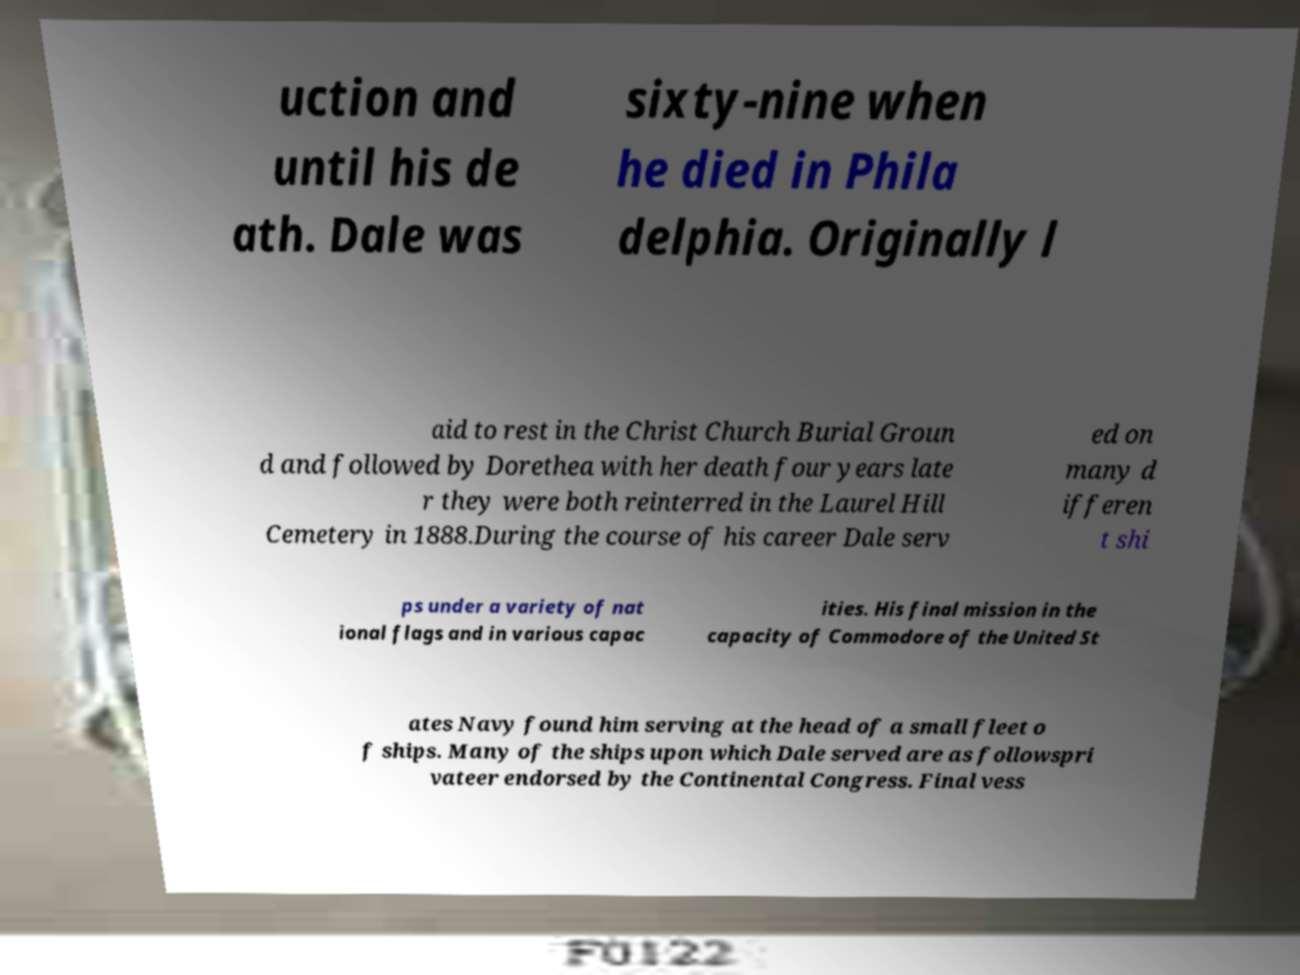I need the written content from this picture converted into text. Can you do that? uction and until his de ath. Dale was sixty-nine when he died in Phila delphia. Originally l aid to rest in the Christ Church Burial Groun d and followed by Dorethea with her death four years late r they were both reinterred in the Laurel Hill Cemetery in 1888.During the course of his career Dale serv ed on many d ifferen t shi ps under a variety of nat ional flags and in various capac ities. His final mission in the capacity of Commodore of the United St ates Navy found him serving at the head of a small fleet o f ships. Many of the ships upon which Dale served are as followspri vateer endorsed by the Continental Congress. Final vess 